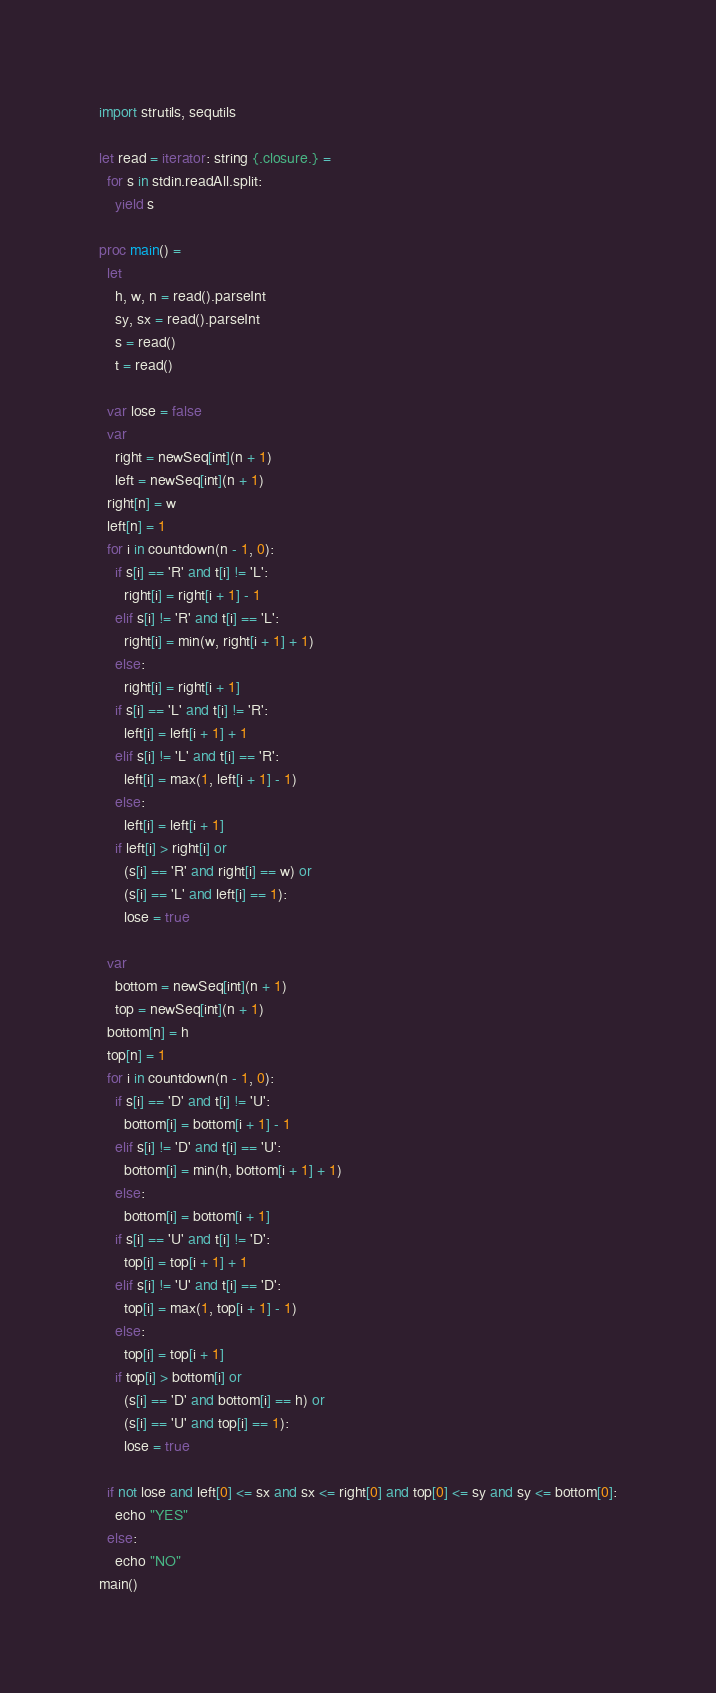<code> <loc_0><loc_0><loc_500><loc_500><_Nim_>import strutils, sequtils

let read = iterator: string {.closure.} =
  for s in stdin.readAll.split:
    yield s

proc main() =
  let
    h, w, n = read().parseInt
    sy, sx = read().parseInt
    s = read()
    t = read()

  var lose = false
  var
    right = newSeq[int](n + 1)
    left = newSeq[int](n + 1)
  right[n] = w
  left[n] = 1
  for i in countdown(n - 1, 0):
    if s[i] == 'R' and t[i] != 'L':
      right[i] = right[i + 1] - 1
    elif s[i] != 'R' and t[i] == 'L':
      right[i] = min(w, right[i + 1] + 1)
    else:
      right[i] = right[i + 1]
    if s[i] == 'L' and t[i] != 'R':
      left[i] = left[i + 1] + 1
    elif s[i] != 'L' and t[i] == 'R':
      left[i] = max(1, left[i + 1] - 1)
    else:
      left[i] = left[i + 1]
    if left[i] > right[i] or
      (s[i] == 'R' and right[i] == w) or
      (s[i] == 'L' and left[i] == 1):
      lose = true

  var
    bottom = newSeq[int](n + 1)
    top = newSeq[int](n + 1)
  bottom[n] = h
  top[n] = 1
  for i in countdown(n - 1, 0):
    if s[i] == 'D' and t[i] != 'U':
      bottom[i] = bottom[i + 1] - 1
    elif s[i] != 'D' and t[i] == 'U':
      bottom[i] = min(h, bottom[i + 1] + 1)
    else:
      bottom[i] = bottom[i + 1]
    if s[i] == 'U' and t[i] != 'D':
      top[i] = top[i + 1] + 1
    elif s[i] != 'U' and t[i] == 'D':
      top[i] = max(1, top[i + 1] - 1)
    else:
      top[i] = top[i + 1]
    if top[i] > bottom[i] or
      (s[i] == 'D' and bottom[i] == h) or
      (s[i] == 'U' and top[i] == 1):
      lose = true

  if not lose and left[0] <= sx and sx <= right[0] and top[0] <= sy and sy <= bottom[0]:
    echo "YES"
  else:
    echo "NO"
main()
</code> 